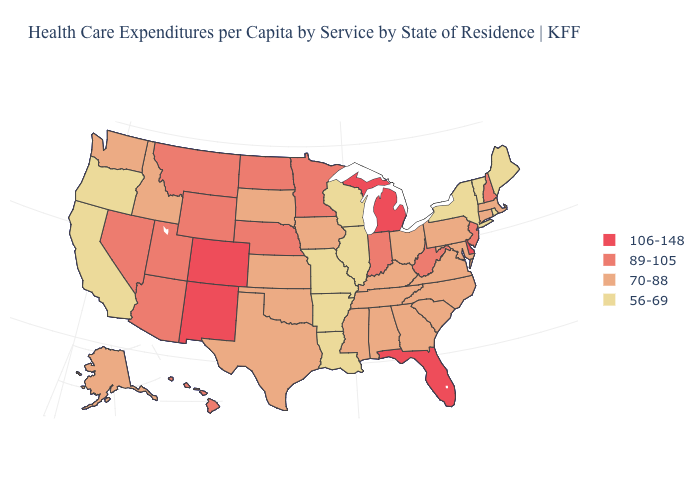How many symbols are there in the legend?
Quick response, please. 4. What is the value of Michigan?
Give a very brief answer. 106-148. Does Illinois have the lowest value in the USA?
Concise answer only. Yes. What is the highest value in the USA?
Keep it brief. 106-148. What is the lowest value in the USA?
Quick response, please. 56-69. What is the value of Ohio?
Be succinct. 70-88. What is the value of Idaho?
Be succinct. 70-88. What is the lowest value in the USA?
Quick response, please. 56-69. Name the states that have a value in the range 70-88?
Short answer required. Alabama, Alaska, Connecticut, Georgia, Idaho, Iowa, Kansas, Kentucky, Maryland, Massachusetts, Mississippi, North Carolina, Ohio, Oklahoma, Pennsylvania, South Carolina, South Dakota, Tennessee, Texas, Virginia, Washington. Name the states that have a value in the range 89-105?
Keep it brief. Arizona, Hawaii, Indiana, Minnesota, Montana, Nebraska, Nevada, New Hampshire, New Jersey, North Dakota, Utah, West Virginia, Wyoming. What is the value of Indiana?
Short answer required. 89-105. Name the states that have a value in the range 56-69?
Give a very brief answer. Arkansas, California, Illinois, Louisiana, Maine, Missouri, New York, Oregon, Rhode Island, Vermont, Wisconsin. Among the states that border Iowa , which have the lowest value?
Keep it brief. Illinois, Missouri, Wisconsin. What is the highest value in the USA?
Write a very short answer. 106-148. 